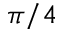Convert formula to latex. <formula><loc_0><loc_0><loc_500><loc_500>\pi / 4</formula> 